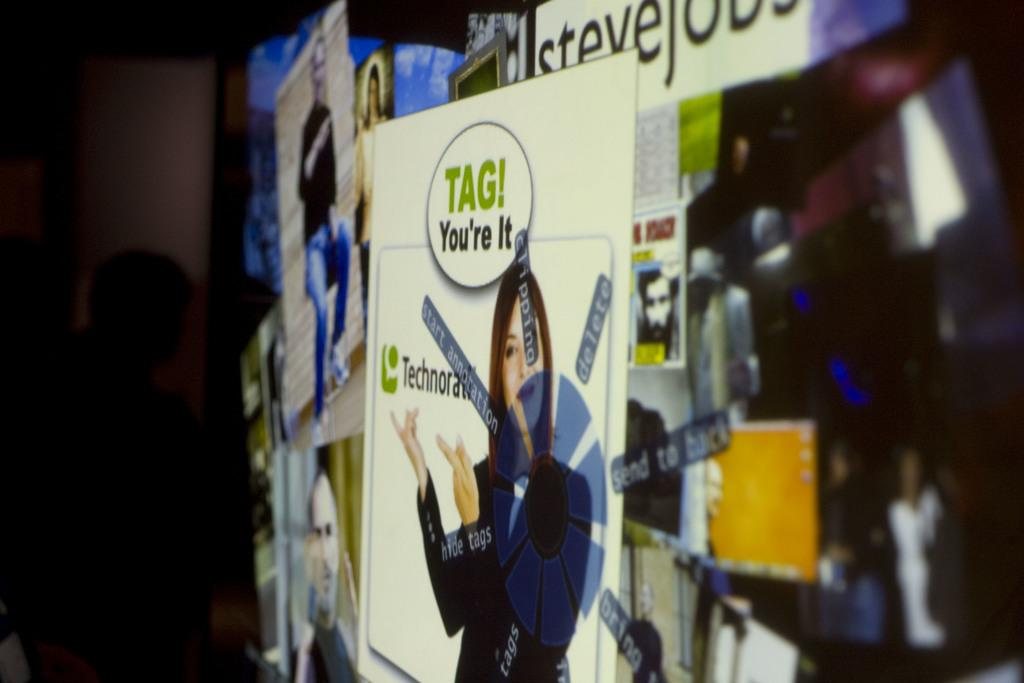<image>
Present a compact description of the photo's key features. An advertisement to Technocrati with the line Tag You're It hangs on a wall. 